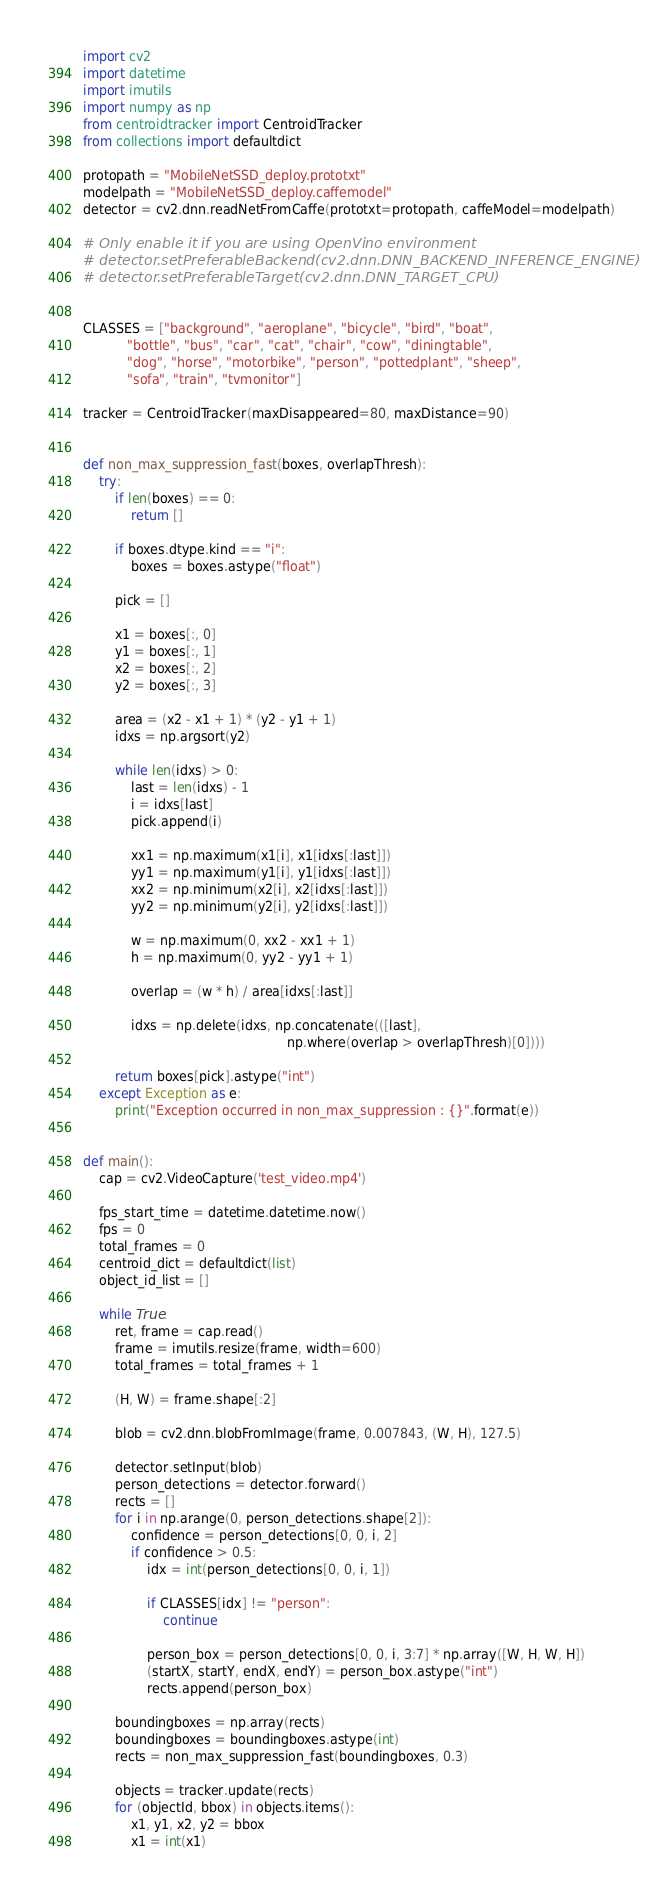<code> <loc_0><loc_0><loc_500><loc_500><_Python_>import cv2
import datetime
import imutils
import numpy as np
from centroidtracker import CentroidTracker
from collections import defaultdict

protopath = "MobileNetSSD_deploy.prototxt"
modelpath = "MobileNetSSD_deploy.caffemodel"
detector = cv2.dnn.readNetFromCaffe(prototxt=protopath, caffeModel=modelpath)

# Only enable it if you are using OpenVino environment
# detector.setPreferableBackend(cv2.dnn.DNN_BACKEND_INFERENCE_ENGINE)
# detector.setPreferableTarget(cv2.dnn.DNN_TARGET_CPU)


CLASSES = ["background", "aeroplane", "bicycle", "bird", "boat",
           "bottle", "bus", "car", "cat", "chair", "cow", "diningtable",
           "dog", "horse", "motorbike", "person", "pottedplant", "sheep",
           "sofa", "train", "tvmonitor"]

tracker = CentroidTracker(maxDisappeared=80, maxDistance=90)


def non_max_suppression_fast(boxes, overlapThresh):
    try:
        if len(boxes) == 0:
            return []

        if boxes.dtype.kind == "i":
            boxes = boxes.astype("float")

        pick = []

        x1 = boxes[:, 0]
        y1 = boxes[:, 1]
        x2 = boxes[:, 2]
        y2 = boxes[:, 3]

        area = (x2 - x1 + 1) * (y2 - y1 + 1)
        idxs = np.argsort(y2)

        while len(idxs) > 0:
            last = len(idxs) - 1
            i = idxs[last]
            pick.append(i)

            xx1 = np.maximum(x1[i], x1[idxs[:last]])
            yy1 = np.maximum(y1[i], y1[idxs[:last]])
            xx2 = np.minimum(x2[i], x2[idxs[:last]])
            yy2 = np.minimum(y2[i], y2[idxs[:last]])

            w = np.maximum(0, xx2 - xx1 + 1)
            h = np.maximum(0, yy2 - yy1 + 1)

            overlap = (w * h) / area[idxs[:last]]

            idxs = np.delete(idxs, np.concatenate(([last],
                                                   np.where(overlap > overlapThresh)[0])))

        return boxes[pick].astype("int")
    except Exception as e:
        print("Exception occurred in non_max_suppression : {}".format(e))


def main():
    cap = cv2.VideoCapture('test_video.mp4')

    fps_start_time = datetime.datetime.now()
    fps = 0
    total_frames = 0
    centroid_dict = defaultdict(list)
    object_id_list = []

    while True:
        ret, frame = cap.read()
        frame = imutils.resize(frame, width=600)
        total_frames = total_frames + 1

        (H, W) = frame.shape[:2]

        blob = cv2.dnn.blobFromImage(frame, 0.007843, (W, H), 127.5)

        detector.setInput(blob)
        person_detections = detector.forward()
        rects = []
        for i in np.arange(0, person_detections.shape[2]):
            confidence = person_detections[0, 0, i, 2]
            if confidence > 0.5:
                idx = int(person_detections[0, 0, i, 1])

                if CLASSES[idx] != "person":
                    continue

                person_box = person_detections[0, 0, i, 3:7] * np.array([W, H, W, H])
                (startX, startY, endX, endY) = person_box.astype("int")
                rects.append(person_box)

        boundingboxes = np.array(rects)
        boundingboxes = boundingboxes.astype(int)
        rects = non_max_suppression_fast(boundingboxes, 0.3)

        objects = tracker.update(rects)
        for (objectId, bbox) in objects.items():
            x1, y1, x2, y2 = bbox
            x1 = int(x1)</code> 